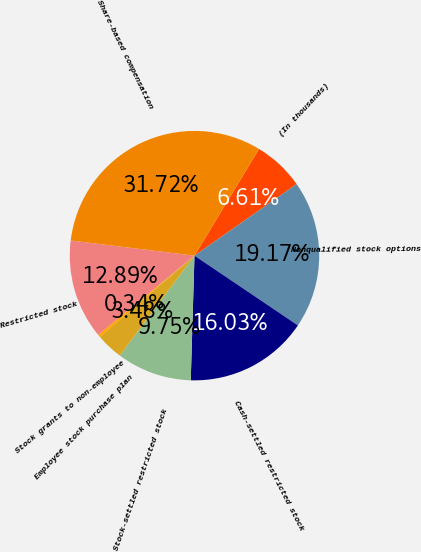Convert chart. <chart><loc_0><loc_0><loc_500><loc_500><pie_chart><fcel>(In thousands)<fcel>Nonqualified stock options<fcel>Cash-settled restricted stock<fcel>Stock-settled restricted stock<fcel>Employee stock purchase plan<fcel>Stock grants to non-employee<fcel>Restricted stock<fcel>Share-based compensation<nl><fcel>6.61%<fcel>19.17%<fcel>16.03%<fcel>9.75%<fcel>3.48%<fcel>0.34%<fcel>12.89%<fcel>31.72%<nl></chart> 